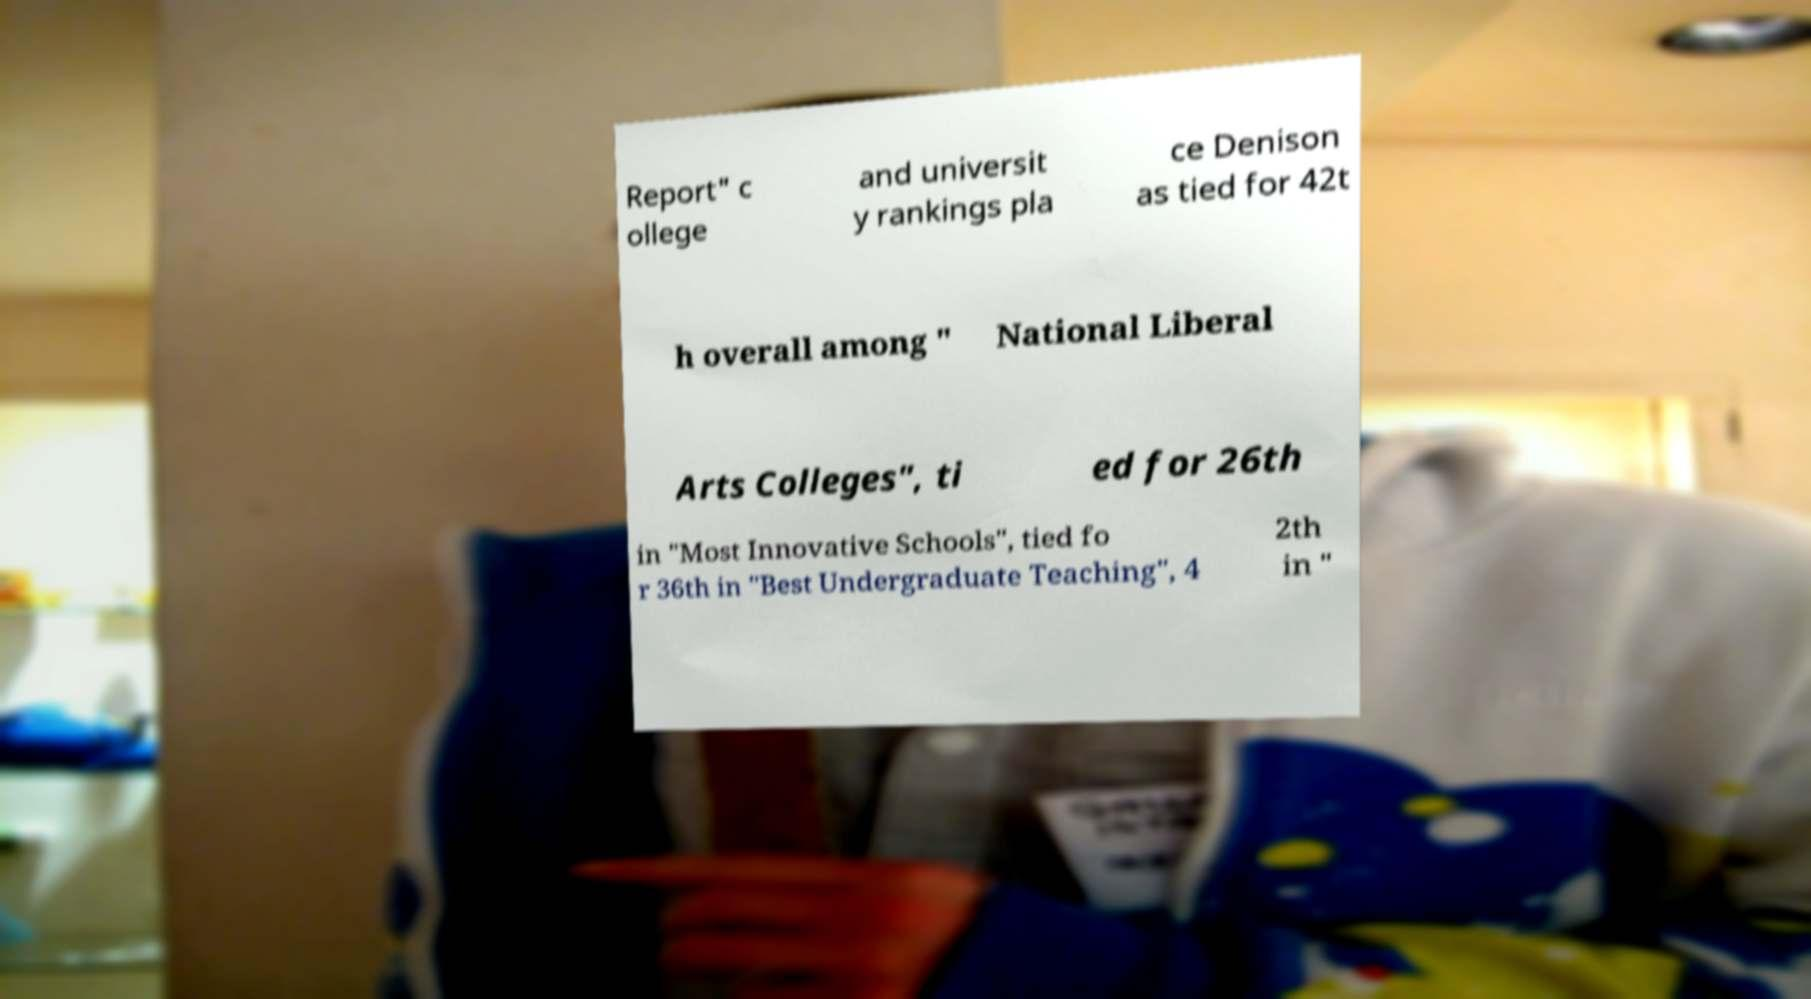There's text embedded in this image that I need extracted. Can you transcribe it verbatim? Report" c ollege and universit y rankings pla ce Denison as tied for 42t h overall among " National Liberal Arts Colleges", ti ed for 26th in "Most Innovative Schools", tied fo r 36th in "Best Undergraduate Teaching", 4 2th in " 